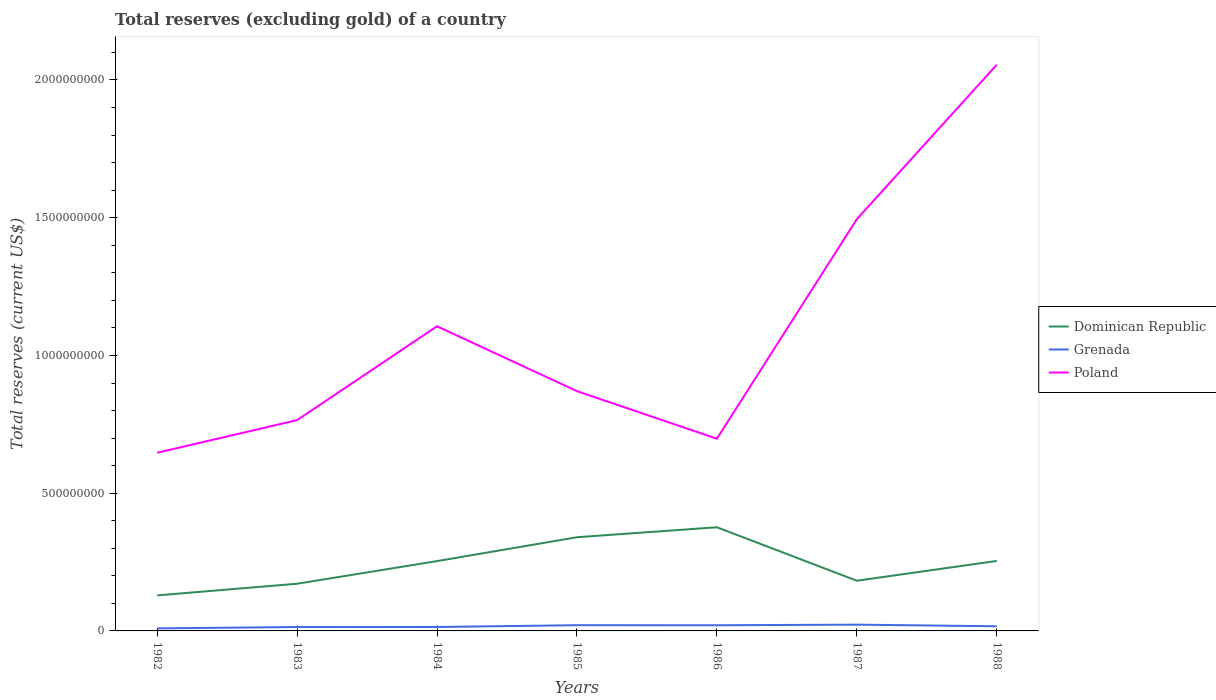Across all years, what is the maximum total reserves (excluding gold) in Poland?
Give a very brief answer. 6.47e+08. What is the total total reserves (excluding gold) in Grenada in the graph?
Provide a succinct answer. -5.00e+06. What is the difference between the highest and the second highest total reserves (excluding gold) in Poland?
Ensure brevity in your answer.  1.41e+09. How many years are there in the graph?
Provide a succinct answer. 7. Are the values on the major ticks of Y-axis written in scientific E-notation?
Provide a short and direct response. No. Does the graph contain grids?
Ensure brevity in your answer.  No. How are the legend labels stacked?
Provide a succinct answer. Vertical. What is the title of the graph?
Your answer should be compact. Total reserves (excluding gold) of a country. Does "Andorra" appear as one of the legend labels in the graph?
Offer a terse response. No. What is the label or title of the Y-axis?
Offer a very short reply. Total reserves (current US$). What is the Total reserves (current US$) of Dominican Republic in 1982?
Give a very brief answer. 1.29e+08. What is the Total reserves (current US$) of Grenada in 1982?
Provide a succinct answer. 9.23e+06. What is the Total reserves (current US$) in Poland in 1982?
Keep it short and to the point. 6.47e+08. What is the Total reserves (current US$) of Dominican Republic in 1983?
Offer a very short reply. 1.71e+08. What is the Total reserves (current US$) of Grenada in 1983?
Make the answer very short. 1.41e+07. What is the Total reserves (current US$) in Poland in 1983?
Ensure brevity in your answer.  7.65e+08. What is the Total reserves (current US$) of Dominican Republic in 1984?
Offer a very short reply. 2.54e+08. What is the Total reserves (current US$) of Grenada in 1984?
Ensure brevity in your answer.  1.42e+07. What is the Total reserves (current US$) of Poland in 1984?
Ensure brevity in your answer.  1.11e+09. What is the Total reserves (current US$) of Dominican Republic in 1985?
Keep it short and to the point. 3.40e+08. What is the Total reserves (current US$) in Grenada in 1985?
Your answer should be compact. 2.08e+07. What is the Total reserves (current US$) in Poland in 1985?
Your response must be concise. 8.70e+08. What is the Total reserves (current US$) in Dominican Republic in 1986?
Ensure brevity in your answer.  3.76e+08. What is the Total reserves (current US$) of Grenada in 1986?
Provide a succinct answer. 2.06e+07. What is the Total reserves (current US$) of Poland in 1986?
Give a very brief answer. 6.98e+08. What is the Total reserves (current US$) in Dominican Republic in 1987?
Make the answer very short. 1.82e+08. What is the Total reserves (current US$) of Grenada in 1987?
Offer a terse response. 2.27e+07. What is the Total reserves (current US$) of Poland in 1987?
Your response must be concise. 1.49e+09. What is the Total reserves (current US$) in Dominican Republic in 1988?
Your response must be concise. 2.54e+08. What is the Total reserves (current US$) of Grenada in 1988?
Give a very brief answer. 1.69e+07. What is the Total reserves (current US$) in Poland in 1988?
Offer a terse response. 2.06e+09. Across all years, what is the maximum Total reserves (current US$) of Dominican Republic?
Keep it short and to the point. 3.76e+08. Across all years, what is the maximum Total reserves (current US$) in Grenada?
Offer a very short reply. 2.27e+07. Across all years, what is the maximum Total reserves (current US$) in Poland?
Give a very brief answer. 2.06e+09. Across all years, what is the minimum Total reserves (current US$) of Dominican Republic?
Offer a terse response. 1.29e+08. Across all years, what is the minimum Total reserves (current US$) in Grenada?
Keep it short and to the point. 9.23e+06. Across all years, what is the minimum Total reserves (current US$) of Poland?
Make the answer very short. 6.47e+08. What is the total Total reserves (current US$) in Dominican Republic in the graph?
Offer a terse response. 1.71e+09. What is the total Total reserves (current US$) in Grenada in the graph?
Make the answer very short. 1.19e+08. What is the total Total reserves (current US$) in Poland in the graph?
Ensure brevity in your answer.  7.64e+09. What is the difference between the Total reserves (current US$) of Dominican Republic in 1982 and that in 1983?
Keep it short and to the point. -4.23e+07. What is the difference between the Total reserves (current US$) of Grenada in 1982 and that in 1983?
Your answer should be compact. -4.91e+06. What is the difference between the Total reserves (current US$) in Poland in 1982 and that in 1983?
Offer a terse response. -1.18e+08. What is the difference between the Total reserves (current US$) in Dominican Republic in 1982 and that in 1984?
Offer a very short reply. -1.25e+08. What is the difference between the Total reserves (current US$) in Grenada in 1982 and that in 1984?
Your answer should be compact. -5.00e+06. What is the difference between the Total reserves (current US$) in Poland in 1982 and that in 1984?
Your answer should be very brief. -4.59e+08. What is the difference between the Total reserves (current US$) of Dominican Republic in 1982 and that in 1985?
Your answer should be compact. -2.11e+08. What is the difference between the Total reserves (current US$) in Grenada in 1982 and that in 1985?
Offer a very short reply. -1.16e+07. What is the difference between the Total reserves (current US$) of Poland in 1982 and that in 1985?
Offer a very short reply. -2.24e+08. What is the difference between the Total reserves (current US$) in Dominican Republic in 1982 and that in 1986?
Your answer should be compact. -2.47e+08. What is the difference between the Total reserves (current US$) of Grenada in 1982 and that in 1986?
Keep it short and to the point. -1.13e+07. What is the difference between the Total reserves (current US$) of Poland in 1982 and that in 1986?
Your answer should be compact. -5.10e+07. What is the difference between the Total reserves (current US$) in Dominican Republic in 1982 and that in 1987?
Give a very brief answer. -5.32e+07. What is the difference between the Total reserves (current US$) in Grenada in 1982 and that in 1987?
Your answer should be compact. -1.35e+07. What is the difference between the Total reserves (current US$) in Poland in 1982 and that in 1987?
Provide a short and direct response. -8.48e+08. What is the difference between the Total reserves (current US$) in Dominican Republic in 1982 and that in 1988?
Keep it short and to the point. -1.25e+08. What is the difference between the Total reserves (current US$) in Grenada in 1982 and that in 1988?
Offer a very short reply. -7.69e+06. What is the difference between the Total reserves (current US$) in Poland in 1982 and that in 1988?
Keep it short and to the point. -1.41e+09. What is the difference between the Total reserves (current US$) in Dominican Republic in 1983 and that in 1984?
Your answer should be compact. -8.22e+07. What is the difference between the Total reserves (current US$) in Grenada in 1983 and that in 1984?
Your answer should be compact. -9.27e+04. What is the difference between the Total reserves (current US$) in Poland in 1983 and that in 1984?
Keep it short and to the point. -3.41e+08. What is the difference between the Total reserves (current US$) in Dominican Republic in 1983 and that in 1985?
Provide a succinct answer. -1.69e+08. What is the difference between the Total reserves (current US$) in Grenada in 1983 and that in 1985?
Keep it short and to the point. -6.67e+06. What is the difference between the Total reserves (current US$) of Poland in 1983 and that in 1985?
Ensure brevity in your answer.  -1.05e+08. What is the difference between the Total reserves (current US$) of Dominican Republic in 1983 and that in 1986?
Provide a short and direct response. -2.05e+08. What is the difference between the Total reserves (current US$) in Grenada in 1983 and that in 1986?
Your answer should be very brief. -6.42e+06. What is the difference between the Total reserves (current US$) in Poland in 1983 and that in 1986?
Your response must be concise. 6.74e+07. What is the difference between the Total reserves (current US$) in Dominican Republic in 1983 and that in 1987?
Ensure brevity in your answer.  -1.09e+07. What is the difference between the Total reserves (current US$) in Grenada in 1983 and that in 1987?
Keep it short and to the point. -8.60e+06. What is the difference between the Total reserves (current US$) in Poland in 1983 and that in 1987?
Make the answer very short. -7.30e+08. What is the difference between the Total reserves (current US$) of Dominican Republic in 1983 and that in 1988?
Your answer should be compact. -8.28e+07. What is the difference between the Total reserves (current US$) of Grenada in 1983 and that in 1988?
Ensure brevity in your answer.  -2.78e+06. What is the difference between the Total reserves (current US$) of Poland in 1983 and that in 1988?
Provide a succinct answer. -1.29e+09. What is the difference between the Total reserves (current US$) in Dominican Republic in 1984 and that in 1985?
Your answer should be very brief. -8.66e+07. What is the difference between the Total reserves (current US$) of Grenada in 1984 and that in 1985?
Give a very brief answer. -6.58e+06. What is the difference between the Total reserves (current US$) in Poland in 1984 and that in 1985?
Keep it short and to the point. 2.36e+08. What is the difference between the Total reserves (current US$) of Dominican Republic in 1984 and that in 1986?
Your answer should be very brief. -1.23e+08. What is the difference between the Total reserves (current US$) of Grenada in 1984 and that in 1986?
Ensure brevity in your answer.  -6.33e+06. What is the difference between the Total reserves (current US$) of Poland in 1984 and that in 1986?
Ensure brevity in your answer.  4.08e+08. What is the difference between the Total reserves (current US$) in Dominican Republic in 1984 and that in 1987?
Make the answer very short. 7.13e+07. What is the difference between the Total reserves (current US$) in Grenada in 1984 and that in 1987?
Your answer should be compact. -8.51e+06. What is the difference between the Total reserves (current US$) in Poland in 1984 and that in 1987?
Give a very brief answer. -3.89e+08. What is the difference between the Total reserves (current US$) of Dominican Republic in 1984 and that in 1988?
Give a very brief answer. -5.38e+05. What is the difference between the Total reserves (current US$) in Grenada in 1984 and that in 1988?
Keep it short and to the point. -2.69e+06. What is the difference between the Total reserves (current US$) in Poland in 1984 and that in 1988?
Make the answer very short. -9.49e+08. What is the difference between the Total reserves (current US$) of Dominican Republic in 1985 and that in 1986?
Your response must be concise. -3.62e+07. What is the difference between the Total reserves (current US$) of Grenada in 1985 and that in 1986?
Offer a terse response. 2.47e+05. What is the difference between the Total reserves (current US$) in Poland in 1985 and that in 1986?
Ensure brevity in your answer.  1.73e+08. What is the difference between the Total reserves (current US$) of Dominican Republic in 1985 and that in 1987?
Keep it short and to the point. 1.58e+08. What is the difference between the Total reserves (current US$) in Grenada in 1985 and that in 1987?
Give a very brief answer. -1.93e+06. What is the difference between the Total reserves (current US$) of Poland in 1985 and that in 1987?
Provide a succinct answer. -6.24e+08. What is the difference between the Total reserves (current US$) in Dominican Republic in 1985 and that in 1988?
Give a very brief answer. 8.61e+07. What is the difference between the Total reserves (current US$) in Grenada in 1985 and that in 1988?
Provide a succinct answer. 3.89e+06. What is the difference between the Total reserves (current US$) in Poland in 1985 and that in 1988?
Give a very brief answer. -1.18e+09. What is the difference between the Total reserves (current US$) of Dominican Republic in 1986 and that in 1987?
Keep it short and to the point. 1.94e+08. What is the difference between the Total reserves (current US$) in Grenada in 1986 and that in 1987?
Make the answer very short. -2.17e+06. What is the difference between the Total reserves (current US$) in Poland in 1986 and that in 1987?
Offer a very short reply. -7.97e+08. What is the difference between the Total reserves (current US$) of Dominican Republic in 1986 and that in 1988?
Make the answer very short. 1.22e+08. What is the difference between the Total reserves (current US$) of Grenada in 1986 and that in 1988?
Your response must be concise. 3.64e+06. What is the difference between the Total reserves (current US$) in Poland in 1986 and that in 1988?
Ensure brevity in your answer.  -1.36e+09. What is the difference between the Total reserves (current US$) in Dominican Republic in 1987 and that in 1988?
Make the answer very short. -7.18e+07. What is the difference between the Total reserves (current US$) of Grenada in 1987 and that in 1988?
Provide a succinct answer. 5.82e+06. What is the difference between the Total reserves (current US$) in Poland in 1987 and that in 1988?
Your answer should be very brief. -5.61e+08. What is the difference between the Total reserves (current US$) of Dominican Republic in 1982 and the Total reserves (current US$) of Grenada in 1983?
Ensure brevity in your answer.  1.15e+08. What is the difference between the Total reserves (current US$) in Dominican Republic in 1982 and the Total reserves (current US$) in Poland in 1983?
Give a very brief answer. -6.36e+08. What is the difference between the Total reserves (current US$) of Grenada in 1982 and the Total reserves (current US$) of Poland in 1983?
Ensure brevity in your answer.  -7.56e+08. What is the difference between the Total reserves (current US$) of Dominican Republic in 1982 and the Total reserves (current US$) of Grenada in 1984?
Offer a terse response. 1.15e+08. What is the difference between the Total reserves (current US$) in Dominican Republic in 1982 and the Total reserves (current US$) in Poland in 1984?
Provide a succinct answer. -9.77e+08. What is the difference between the Total reserves (current US$) in Grenada in 1982 and the Total reserves (current US$) in Poland in 1984?
Ensure brevity in your answer.  -1.10e+09. What is the difference between the Total reserves (current US$) in Dominican Republic in 1982 and the Total reserves (current US$) in Grenada in 1985?
Make the answer very short. 1.08e+08. What is the difference between the Total reserves (current US$) in Dominican Republic in 1982 and the Total reserves (current US$) in Poland in 1985?
Provide a succinct answer. -7.41e+08. What is the difference between the Total reserves (current US$) of Grenada in 1982 and the Total reserves (current US$) of Poland in 1985?
Ensure brevity in your answer.  -8.61e+08. What is the difference between the Total reserves (current US$) in Dominican Republic in 1982 and the Total reserves (current US$) in Grenada in 1986?
Provide a short and direct response. 1.08e+08. What is the difference between the Total reserves (current US$) of Dominican Republic in 1982 and the Total reserves (current US$) of Poland in 1986?
Give a very brief answer. -5.69e+08. What is the difference between the Total reserves (current US$) of Grenada in 1982 and the Total reserves (current US$) of Poland in 1986?
Offer a terse response. -6.89e+08. What is the difference between the Total reserves (current US$) of Dominican Republic in 1982 and the Total reserves (current US$) of Grenada in 1987?
Provide a short and direct response. 1.06e+08. What is the difference between the Total reserves (current US$) of Dominican Republic in 1982 and the Total reserves (current US$) of Poland in 1987?
Make the answer very short. -1.37e+09. What is the difference between the Total reserves (current US$) in Grenada in 1982 and the Total reserves (current US$) in Poland in 1987?
Provide a succinct answer. -1.49e+09. What is the difference between the Total reserves (current US$) of Dominican Republic in 1982 and the Total reserves (current US$) of Grenada in 1988?
Give a very brief answer. 1.12e+08. What is the difference between the Total reserves (current US$) in Dominican Republic in 1982 and the Total reserves (current US$) in Poland in 1988?
Ensure brevity in your answer.  -1.93e+09. What is the difference between the Total reserves (current US$) in Grenada in 1982 and the Total reserves (current US$) in Poland in 1988?
Provide a succinct answer. -2.05e+09. What is the difference between the Total reserves (current US$) in Dominican Republic in 1983 and the Total reserves (current US$) in Grenada in 1984?
Your answer should be very brief. 1.57e+08. What is the difference between the Total reserves (current US$) in Dominican Republic in 1983 and the Total reserves (current US$) in Poland in 1984?
Your answer should be very brief. -9.35e+08. What is the difference between the Total reserves (current US$) in Grenada in 1983 and the Total reserves (current US$) in Poland in 1984?
Your answer should be very brief. -1.09e+09. What is the difference between the Total reserves (current US$) in Dominican Republic in 1983 and the Total reserves (current US$) in Grenada in 1985?
Ensure brevity in your answer.  1.50e+08. What is the difference between the Total reserves (current US$) in Dominican Republic in 1983 and the Total reserves (current US$) in Poland in 1985?
Ensure brevity in your answer.  -6.99e+08. What is the difference between the Total reserves (current US$) in Grenada in 1983 and the Total reserves (current US$) in Poland in 1985?
Provide a succinct answer. -8.56e+08. What is the difference between the Total reserves (current US$) of Dominican Republic in 1983 and the Total reserves (current US$) of Grenada in 1986?
Offer a very short reply. 1.51e+08. What is the difference between the Total reserves (current US$) in Dominican Republic in 1983 and the Total reserves (current US$) in Poland in 1986?
Make the answer very short. -5.27e+08. What is the difference between the Total reserves (current US$) of Grenada in 1983 and the Total reserves (current US$) of Poland in 1986?
Make the answer very short. -6.84e+08. What is the difference between the Total reserves (current US$) of Dominican Republic in 1983 and the Total reserves (current US$) of Grenada in 1987?
Provide a succinct answer. 1.49e+08. What is the difference between the Total reserves (current US$) of Dominican Republic in 1983 and the Total reserves (current US$) of Poland in 1987?
Your response must be concise. -1.32e+09. What is the difference between the Total reserves (current US$) in Grenada in 1983 and the Total reserves (current US$) in Poland in 1987?
Keep it short and to the point. -1.48e+09. What is the difference between the Total reserves (current US$) of Dominican Republic in 1983 and the Total reserves (current US$) of Grenada in 1988?
Give a very brief answer. 1.54e+08. What is the difference between the Total reserves (current US$) of Dominican Republic in 1983 and the Total reserves (current US$) of Poland in 1988?
Provide a succinct answer. -1.88e+09. What is the difference between the Total reserves (current US$) in Grenada in 1983 and the Total reserves (current US$) in Poland in 1988?
Your answer should be compact. -2.04e+09. What is the difference between the Total reserves (current US$) in Dominican Republic in 1984 and the Total reserves (current US$) in Grenada in 1985?
Offer a terse response. 2.33e+08. What is the difference between the Total reserves (current US$) in Dominican Republic in 1984 and the Total reserves (current US$) in Poland in 1985?
Offer a terse response. -6.17e+08. What is the difference between the Total reserves (current US$) of Grenada in 1984 and the Total reserves (current US$) of Poland in 1985?
Provide a short and direct response. -8.56e+08. What is the difference between the Total reserves (current US$) in Dominican Republic in 1984 and the Total reserves (current US$) in Grenada in 1986?
Provide a succinct answer. 2.33e+08. What is the difference between the Total reserves (current US$) of Dominican Republic in 1984 and the Total reserves (current US$) of Poland in 1986?
Your response must be concise. -4.44e+08. What is the difference between the Total reserves (current US$) of Grenada in 1984 and the Total reserves (current US$) of Poland in 1986?
Make the answer very short. -6.84e+08. What is the difference between the Total reserves (current US$) of Dominican Republic in 1984 and the Total reserves (current US$) of Grenada in 1987?
Your response must be concise. 2.31e+08. What is the difference between the Total reserves (current US$) of Dominican Republic in 1984 and the Total reserves (current US$) of Poland in 1987?
Provide a short and direct response. -1.24e+09. What is the difference between the Total reserves (current US$) in Grenada in 1984 and the Total reserves (current US$) in Poland in 1987?
Keep it short and to the point. -1.48e+09. What is the difference between the Total reserves (current US$) of Dominican Republic in 1984 and the Total reserves (current US$) of Grenada in 1988?
Provide a succinct answer. 2.37e+08. What is the difference between the Total reserves (current US$) in Dominican Republic in 1984 and the Total reserves (current US$) in Poland in 1988?
Your answer should be compact. -1.80e+09. What is the difference between the Total reserves (current US$) in Grenada in 1984 and the Total reserves (current US$) in Poland in 1988?
Give a very brief answer. -2.04e+09. What is the difference between the Total reserves (current US$) in Dominican Republic in 1985 and the Total reserves (current US$) in Grenada in 1986?
Provide a short and direct response. 3.20e+08. What is the difference between the Total reserves (current US$) of Dominican Republic in 1985 and the Total reserves (current US$) of Poland in 1986?
Provide a short and direct response. -3.58e+08. What is the difference between the Total reserves (current US$) of Grenada in 1985 and the Total reserves (current US$) of Poland in 1986?
Your response must be concise. -6.77e+08. What is the difference between the Total reserves (current US$) in Dominican Republic in 1985 and the Total reserves (current US$) in Grenada in 1987?
Offer a terse response. 3.17e+08. What is the difference between the Total reserves (current US$) in Dominican Republic in 1985 and the Total reserves (current US$) in Poland in 1987?
Ensure brevity in your answer.  -1.15e+09. What is the difference between the Total reserves (current US$) of Grenada in 1985 and the Total reserves (current US$) of Poland in 1987?
Provide a short and direct response. -1.47e+09. What is the difference between the Total reserves (current US$) of Dominican Republic in 1985 and the Total reserves (current US$) of Grenada in 1988?
Ensure brevity in your answer.  3.23e+08. What is the difference between the Total reserves (current US$) of Dominican Republic in 1985 and the Total reserves (current US$) of Poland in 1988?
Provide a short and direct response. -1.72e+09. What is the difference between the Total reserves (current US$) of Grenada in 1985 and the Total reserves (current US$) of Poland in 1988?
Provide a succinct answer. -2.03e+09. What is the difference between the Total reserves (current US$) in Dominican Republic in 1986 and the Total reserves (current US$) in Grenada in 1987?
Your response must be concise. 3.54e+08. What is the difference between the Total reserves (current US$) of Dominican Republic in 1986 and the Total reserves (current US$) of Poland in 1987?
Your answer should be compact. -1.12e+09. What is the difference between the Total reserves (current US$) of Grenada in 1986 and the Total reserves (current US$) of Poland in 1987?
Your answer should be compact. -1.47e+09. What is the difference between the Total reserves (current US$) of Dominican Republic in 1986 and the Total reserves (current US$) of Grenada in 1988?
Your answer should be compact. 3.59e+08. What is the difference between the Total reserves (current US$) in Dominican Republic in 1986 and the Total reserves (current US$) in Poland in 1988?
Offer a terse response. -1.68e+09. What is the difference between the Total reserves (current US$) in Grenada in 1986 and the Total reserves (current US$) in Poland in 1988?
Provide a succinct answer. -2.03e+09. What is the difference between the Total reserves (current US$) of Dominican Republic in 1987 and the Total reserves (current US$) of Grenada in 1988?
Make the answer very short. 1.65e+08. What is the difference between the Total reserves (current US$) in Dominican Republic in 1987 and the Total reserves (current US$) in Poland in 1988?
Your response must be concise. -1.87e+09. What is the difference between the Total reserves (current US$) in Grenada in 1987 and the Total reserves (current US$) in Poland in 1988?
Provide a succinct answer. -2.03e+09. What is the average Total reserves (current US$) in Dominican Republic per year?
Your answer should be very brief. 2.44e+08. What is the average Total reserves (current US$) in Grenada per year?
Offer a terse response. 1.69e+07. What is the average Total reserves (current US$) in Poland per year?
Make the answer very short. 1.09e+09. In the year 1982, what is the difference between the Total reserves (current US$) of Dominican Republic and Total reserves (current US$) of Grenada?
Your answer should be compact. 1.20e+08. In the year 1982, what is the difference between the Total reserves (current US$) in Dominican Republic and Total reserves (current US$) in Poland?
Provide a short and direct response. -5.18e+08. In the year 1982, what is the difference between the Total reserves (current US$) of Grenada and Total reserves (current US$) of Poland?
Ensure brevity in your answer.  -6.38e+08. In the year 1983, what is the difference between the Total reserves (current US$) of Dominican Republic and Total reserves (current US$) of Grenada?
Provide a succinct answer. 1.57e+08. In the year 1983, what is the difference between the Total reserves (current US$) in Dominican Republic and Total reserves (current US$) in Poland?
Ensure brevity in your answer.  -5.94e+08. In the year 1983, what is the difference between the Total reserves (current US$) in Grenada and Total reserves (current US$) in Poland?
Offer a very short reply. -7.51e+08. In the year 1984, what is the difference between the Total reserves (current US$) of Dominican Republic and Total reserves (current US$) of Grenada?
Provide a succinct answer. 2.39e+08. In the year 1984, what is the difference between the Total reserves (current US$) of Dominican Republic and Total reserves (current US$) of Poland?
Your response must be concise. -8.52e+08. In the year 1984, what is the difference between the Total reserves (current US$) in Grenada and Total reserves (current US$) in Poland?
Make the answer very short. -1.09e+09. In the year 1985, what is the difference between the Total reserves (current US$) of Dominican Republic and Total reserves (current US$) of Grenada?
Offer a terse response. 3.19e+08. In the year 1985, what is the difference between the Total reserves (current US$) of Dominican Republic and Total reserves (current US$) of Poland?
Ensure brevity in your answer.  -5.30e+08. In the year 1985, what is the difference between the Total reserves (current US$) of Grenada and Total reserves (current US$) of Poland?
Your response must be concise. -8.50e+08. In the year 1986, what is the difference between the Total reserves (current US$) in Dominican Republic and Total reserves (current US$) in Grenada?
Offer a terse response. 3.56e+08. In the year 1986, what is the difference between the Total reserves (current US$) in Dominican Republic and Total reserves (current US$) in Poland?
Keep it short and to the point. -3.21e+08. In the year 1986, what is the difference between the Total reserves (current US$) of Grenada and Total reserves (current US$) of Poland?
Your response must be concise. -6.77e+08. In the year 1987, what is the difference between the Total reserves (current US$) of Dominican Republic and Total reserves (current US$) of Grenada?
Your answer should be compact. 1.59e+08. In the year 1987, what is the difference between the Total reserves (current US$) of Dominican Republic and Total reserves (current US$) of Poland?
Your answer should be compact. -1.31e+09. In the year 1987, what is the difference between the Total reserves (current US$) of Grenada and Total reserves (current US$) of Poland?
Keep it short and to the point. -1.47e+09. In the year 1988, what is the difference between the Total reserves (current US$) in Dominican Republic and Total reserves (current US$) in Grenada?
Your answer should be very brief. 2.37e+08. In the year 1988, what is the difference between the Total reserves (current US$) in Dominican Republic and Total reserves (current US$) in Poland?
Give a very brief answer. -1.80e+09. In the year 1988, what is the difference between the Total reserves (current US$) of Grenada and Total reserves (current US$) of Poland?
Give a very brief answer. -2.04e+09. What is the ratio of the Total reserves (current US$) of Dominican Republic in 1982 to that in 1983?
Your answer should be very brief. 0.75. What is the ratio of the Total reserves (current US$) of Grenada in 1982 to that in 1983?
Provide a short and direct response. 0.65. What is the ratio of the Total reserves (current US$) of Poland in 1982 to that in 1983?
Your answer should be compact. 0.85. What is the ratio of the Total reserves (current US$) of Dominican Republic in 1982 to that in 1984?
Ensure brevity in your answer.  0.51. What is the ratio of the Total reserves (current US$) in Grenada in 1982 to that in 1984?
Make the answer very short. 0.65. What is the ratio of the Total reserves (current US$) of Poland in 1982 to that in 1984?
Offer a terse response. 0.58. What is the ratio of the Total reserves (current US$) of Dominican Republic in 1982 to that in 1985?
Your answer should be very brief. 0.38. What is the ratio of the Total reserves (current US$) of Grenada in 1982 to that in 1985?
Your response must be concise. 0.44. What is the ratio of the Total reserves (current US$) in Poland in 1982 to that in 1985?
Provide a short and direct response. 0.74. What is the ratio of the Total reserves (current US$) of Dominican Republic in 1982 to that in 1986?
Give a very brief answer. 0.34. What is the ratio of the Total reserves (current US$) of Grenada in 1982 to that in 1986?
Provide a short and direct response. 0.45. What is the ratio of the Total reserves (current US$) of Poland in 1982 to that in 1986?
Provide a succinct answer. 0.93. What is the ratio of the Total reserves (current US$) of Dominican Republic in 1982 to that in 1987?
Give a very brief answer. 0.71. What is the ratio of the Total reserves (current US$) of Grenada in 1982 to that in 1987?
Keep it short and to the point. 0.41. What is the ratio of the Total reserves (current US$) in Poland in 1982 to that in 1987?
Keep it short and to the point. 0.43. What is the ratio of the Total reserves (current US$) in Dominican Republic in 1982 to that in 1988?
Make the answer very short. 0.51. What is the ratio of the Total reserves (current US$) in Grenada in 1982 to that in 1988?
Your answer should be compact. 0.55. What is the ratio of the Total reserves (current US$) of Poland in 1982 to that in 1988?
Provide a succinct answer. 0.31. What is the ratio of the Total reserves (current US$) of Dominican Republic in 1983 to that in 1984?
Make the answer very short. 0.68. What is the ratio of the Total reserves (current US$) in Poland in 1983 to that in 1984?
Make the answer very short. 0.69. What is the ratio of the Total reserves (current US$) in Dominican Republic in 1983 to that in 1985?
Offer a terse response. 0.5. What is the ratio of the Total reserves (current US$) of Grenada in 1983 to that in 1985?
Provide a short and direct response. 0.68. What is the ratio of the Total reserves (current US$) in Poland in 1983 to that in 1985?
Offer a very short reply. 0.88. What is the ratio of the Total reserves (current US$) in Dominican Republic in 1983 to that in 1986?
Offer a terse response. 0.46. What is the ratio of the Total reserves (current US$) in Grenada in 1983 to that in 1986?
Give a very brief answer. 0.69. What is the ratio of the Total reserves (current US$) of Poland in 1983 to that in 1986?
Your answer should be compact. 1.1. What is the ratio of the Total reserves (current US$) of Dominican Republic in 1983 to that in 1987?
Provide a short and direct response. 0.94. What is the ratio of the Total reserves (current US$) in Grenada in 1983 to that in 1987?
Provide a succinct answer. 0.62. What is the ratio of the Total reserves (current US$) in Poland in 1983 to that in 1987?
Offer a very short reply. 0.51. What is the ratio of the Total reserves (current US$) in Dominican Republic in 1983 to that in 1988?
Make the answer very short. 0.67. What is the ratio of the Total reserves (current US$) in Grenada in 1983 to that in 1988?
Make the answer very short. 0.84. What is the ratio of the Total reserves (current US$) of Poland in 1983 to that in 1988?
Your answer should be compact. 0.37. What is the ratio of the Total reserves (current US$) in Dominican Republic in 1984 to that in 1985?
Give a very brief answer. 0.75. What is the ratio of the Total reserves (current US$) of Grenada in 1984 to that in 1985?
Give a very brief answer. 0.68. What is the ratio of the Total reserves (current US$) in Poland in 1984 to that in 1985?
Keep it short and to the point. 1.27. What is the ratio of the Total reserves (current US$) of Dominican Republic in 1984 to that in 1986?
Your response must be concise. 0.67. What is the ratio of the Total reserves (current US$) of Grenada in 1984 to that in 1986?
Make the answer very short. 0.69. What is the ratio of the Total reserves (current US$) in Poland in 1984 to that in 1986?
Keep it short and to the point. 1.58. What is the ratio of the Total reserves (current US$) of Dominican Republic in 1984 to that in 1987?
Offer a terse response. 1.39. What is the ratio of the Total reserves (current US$) in Grenada in 1984 to that in 1987?
Make the answer very short. 0.63. What is the ratio of the Total reserves (current US$) in Poland in 1984 to that in 1987?
Your answer should be compact. 0.74. What is the ratio of the Total reserves (current US$) in Dominican Republic in 1984 to that in 1988?
Ensure brevity in your answer.  1. What is the ratio of the Total reserves (current US$) in Grenada in 1984 to that in 1988?
Offer a very short reply. 0.84. What is the ratio of the Total reserves (current US$) in Poland in 1984 to that in 1988?
Your response must be concise. 0.54. What is the ratio of the Total reserves (current US$) of Dominican Republic in 1985 to that in 1986?
Offer a terse response. 0.9. What is the ratio of the Total reserves (current US$) of Grenada in 1985 to that in 1986?
Provide a short and direct response. 1.01. What is the ratio of the Total reserves (current US$) of Poland in 1985 to that in 1986?
Provide a short and direct response. 1.25. What is the ratio of the Total reserves (current US$) of Dominican Republic in 1985 to that in 1987?
Your answer should be very brief. 1.87. What is the ratio of the Total reserves (current US$) of Grenada in 1985 to that in 1987?
Offer a terse response. 0.92. What is the ratio of the Total reserves (current US$) in Poland in 1985 to that in 1987?
Give a very brief answer. 0.58. What is the ratio of the Total reserves (current US$) in Dominican Republic in 1985 to that in 1988?
Your answer should be very brief. 1.34. What is the ratio of the Total reserves (current US$) in Grenada in 1985 to that in 1988?
Make the answer very short. 1.23. What is the ratio of the Total reserves (current US$) of Poland in 1985 to that in 1988?
Give a very brief answer. 0.42. What is the ratio of the Total reserves (current US$) in Dominican Republic in 1986 to that in 1987?
Ensure brevity in your answer.  2.07. What is the ratio of the Total reserves (current US$) of Grenada in 1986 to that in 1987?
Offer a very short reply. 0.9. What is the ratio of the Total reserves (current US$) in Poland in 1986 to that in 1987?
Your answer should be very brief. 0.47. What is the ratio of the Total reserves (current US$) of Dominican Republic in 1986 to that in 1988?
Provide a succinct answer. 1.48. What is the ratio of the Total reserves (current US$) in Grenada in 1986 to that in 1988?
Your response must be concise. 1.22. What is the ratio of the Total reserves (current US$) in Poland in 1986 to that in 1988?
Your answer should be compact. 0.34. What is the ratio of the Total reserves (current US$) in Dominican Republic in 1987 to that in 1988?
Ensure brevity in your answer.  0.72. What is the ratio of the Total reserves (current US$) in Grenada in 1987 to that in 1988?
Provide a short and direct response. 1.34. What is the ratio of the Total reserves (current US$) of Poland in 1987 to that in 1988?
Provide a short and direct response. 0.73. What is the difference between the highest and the second highest Total reserves (current US$) of Dominican Republic?
Make the answer very short. 3.62e+07. What is the difference between the highest and the second highest Total reserves (current US$) of Grenada?
Keep it short and to the point. 1.93e+06. What is the difference between the highest and the second highest Total reserves (current US$) in Poland?
Your answer should be very brief. 5.61e+08. What is the difference between the highest and the lowest Total reserves (current US$) of Dominican Republic?
Your answer should be very brief. 2.47e+08. What is the difference between the highest and the lowest Total reserves (current US$) in Grenada?
Keep it short and to the point. 1.35e+07. What is the difference between the highest and the lowest Total reserves (current US$) of Poland?
Your answer should be very brief. 1.41e+09. 